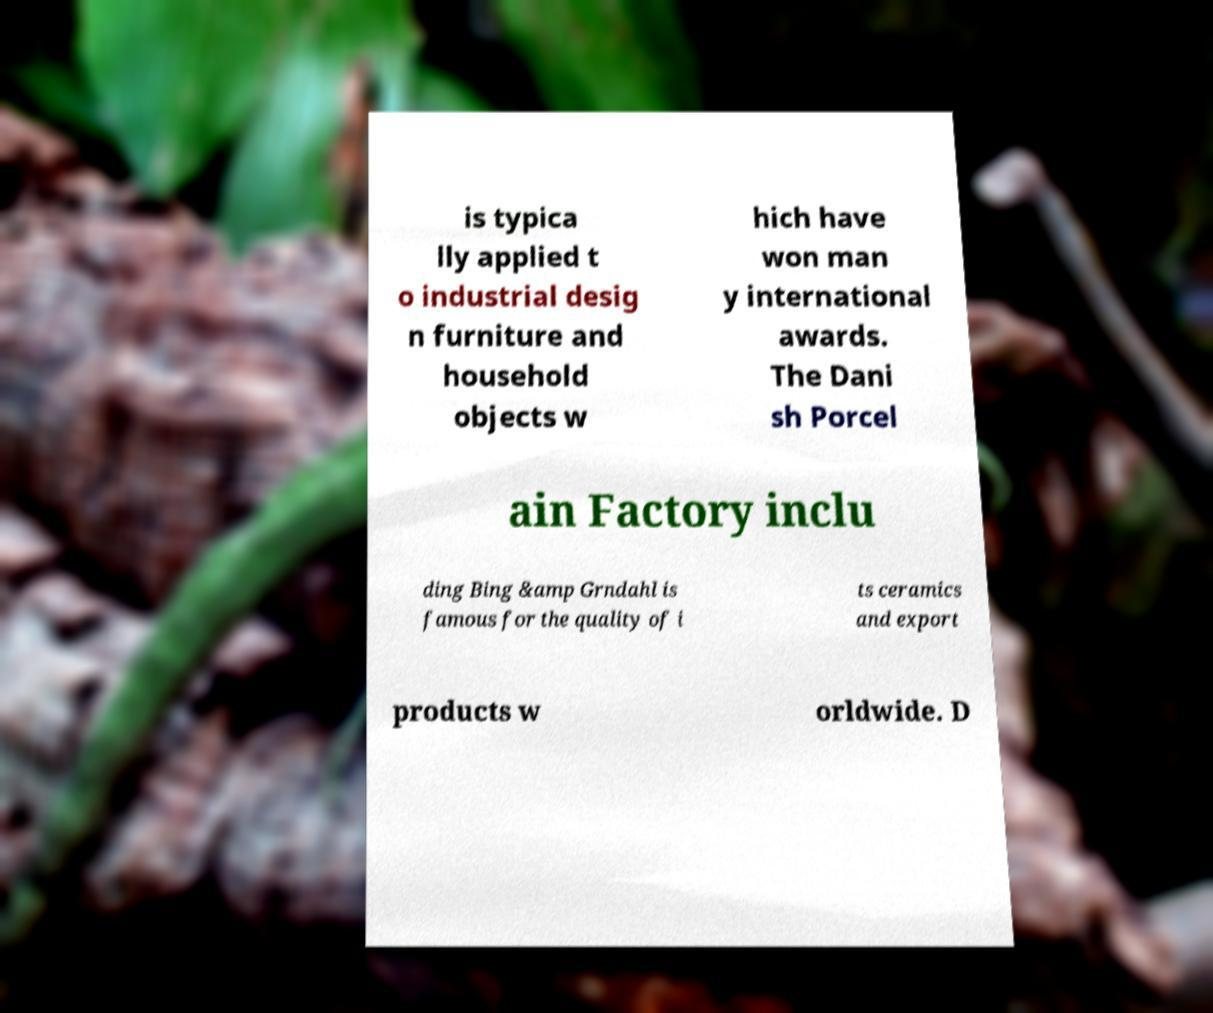For documentation purposes, I need the text within this image transcribed. Could you provide that? is typica lly applied t o industrial desig n furniture and household objects w hich have won man y international awards. The Dani sh Porcel ain Factory inclu ding Bing &amp Grndahl is famous for the quality of i ts ceramics and export products w orldwide. D 